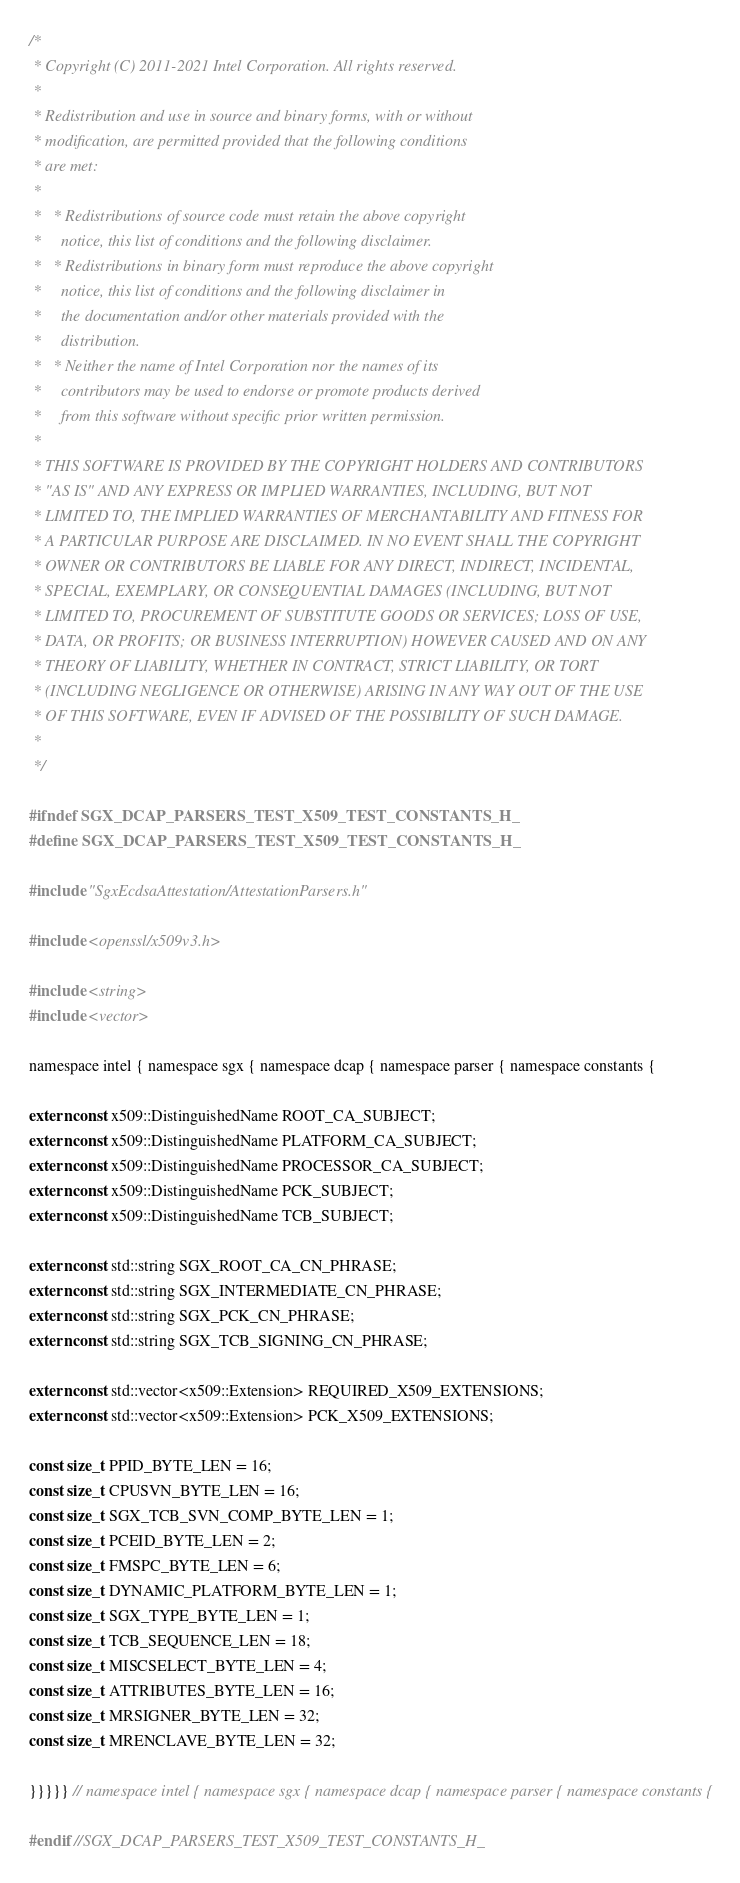<code> <loc_0><loc_0><loc_500><loc_500><_C_>/*
 * Copyright (C) 2011-2021 Intel Corporation. All rights reserved.
 *
 * Redistribution and use in source and binary forms, with or without
 * modification, are permitted provided that the following conditions
 * are met:
 *
 *   * Redistributions of source code must retain the above copyright
 *     notice, this list of conditions and the following disclaimer.
 *   * Redistributions in binary form must reproduce the above copyright
 *     notice, this list of conditions and the following disclaimer in
 *     the documentation and/or other materials provided with the
 *     distribution.
 *   * Neither the name of Intel Corporation nor the names of its
 *     contributors may be used to endorse or promote products derived
 *     from this software without specific prior written permission.
 *
 * THIS SOFTWARE IS PROVIDED BY THE COPYRIGHT HOLDERS AND CONTRIBUTORS
 * "AS IS" AND ANY EXPRESS OR IMPLIED WARRANTIES, INCLUDING, BUT NOT
 * LIMITED TO, THE IMPLIED WARRANTIES OF MERCHANTABILITY AND FITNESS FOR
 * A PARTICULAR PURPOSE ARE DISCLAIMED. IN NO EVENT SHALL THE COPYRIGHT
 * OWNER OR CONTRIBUTORS BE LIABLE FOR ANY DIRECT, INDIRECT, INCIDENTAL,
 * SPECIAL, EXEMPLARY, OR CONSEQUENTIAL DAMAGES (INCLUDING, BUT NOT
 * LIMITED TO, PROCUREMENT OF SUBSTITUTE GOODS OR SERVICES; LOSS OF USE,
 * DATA, OR PROFITS; OR BUSINESS INTERRUPTION) HOWEVER CAUSED AND ON ANY
 * THEORY OF LIABILITY, WHETHER IN CONTRACT, STRICT LIABILITY, OR TORT
 * (INCLUDING NEGLIGENCE OR OTHERWISE) ARISING IN ANY WAY OUT OF THE USE
 * OF THIS SOFTWARE, EVEN IF ADVISED OF THE POSSIBILITY OF SUCH DAMAGE.
 *
 */

#ifndef SGX_DCAP_PARSERS_TEST_X509_TEST_CONSTANTS_H_
#define SGX_DCAP_PARSERS_TEST_X509_TEST_CONSTANTS_H_

#include "SgxEcdsaAttestation/AttestationParsers.h"

#include <openssl/x509v3.h>

#include <string>
#include <vector>

namespace intel { namespace sgx { namespace dcap { namespace parser { namespace constants {

extern const x509::DistinguishedName ROOT_CA_SUBJECT;
extern const x509::DistinguishedName PLATFORM_CA_SUBJECT;
extern const x509::DistinguishedName PROCESSOR_CA_SUBJECT;
extern const x509::DistinguishedName PCK_SUBJECT;
extern const x509::DistinguishedName TCB_SUBJECT;

extern const std::string SGX_ROOT_CA_CN_PHRASE;
extern const std::string SGX_INTERMEDIATE_CN_PHRASE;
extern const std::string SGX_PCK_CN_PHRASE;
extern const std::string SGX_TCB_SIGNING_CN_PHRASE;

extern const std::vector<x509::Extension> REQUIRED_X509_EXTENSIONS;
extern const std::vector<x509::Extension> PCK_X509_EXTENSIONS;

const size_t PPID_BYTE_LEN = 16;
const size_t CPUSVN_BYTE_LEN = 16;
const size_t SGX_TCB_SVN_COMP_BYTE_LEN = 1;
const size_t PCEID_BYTE_LEN = 2;
const size_t FMSPC_BYTE_LEN = 6;
const size_t DYNAMIC_PLATFORM_BYTE_LEN = 1;
const size_t SGX_TYPE_BYTE_LEN = 1;
const size_t TCB_SEQUENCE_LEN = 18;
const size_t MISCSELECT_BYTE_LEN = 4;
const size_t ATTRIBUTES_BYTE_LEN = 16;
const size_t MRSIGNER_BYTE_LEN = 32;
const size_t MRENCLAVE_BYTE_LEN = 32;

}}}}} // namespace intel { namespace sgx { namespace dcap { namespace parser { namespace constants {

#endif //SGX_DCAP_PARSERS_TEST_X509_TEST_CONSTANTS_H_
</code> 